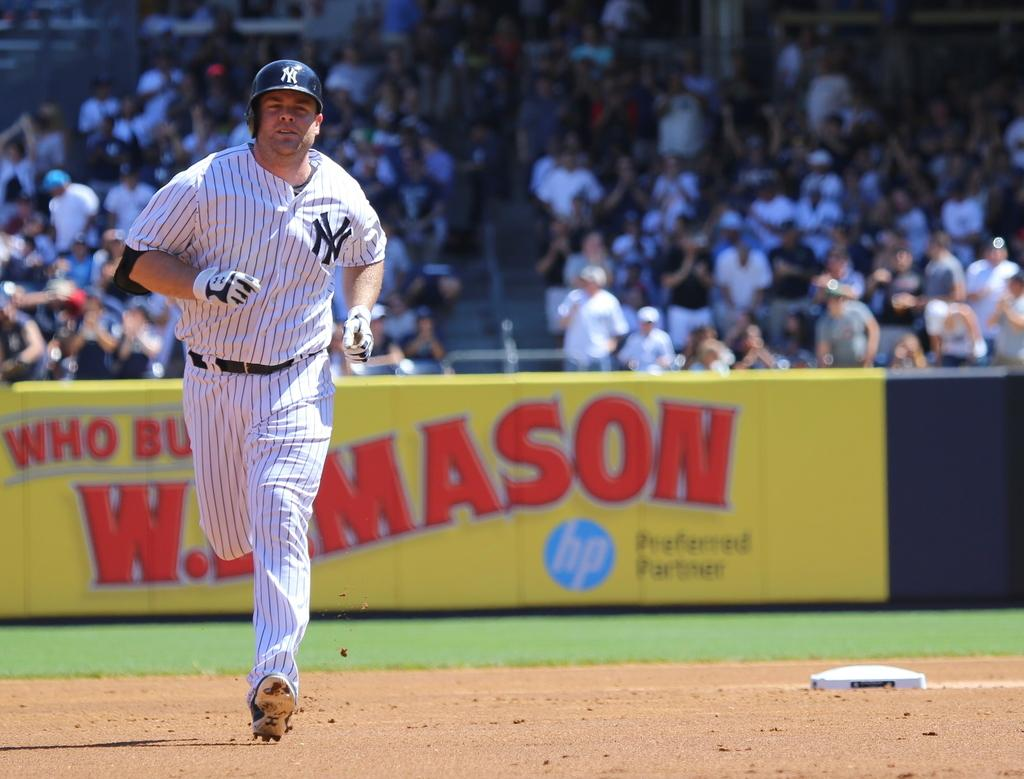<image>
Relay a brief, clear account of the picture shown. A baseball player in a white and blue uniform with the new york logo on his chest. 